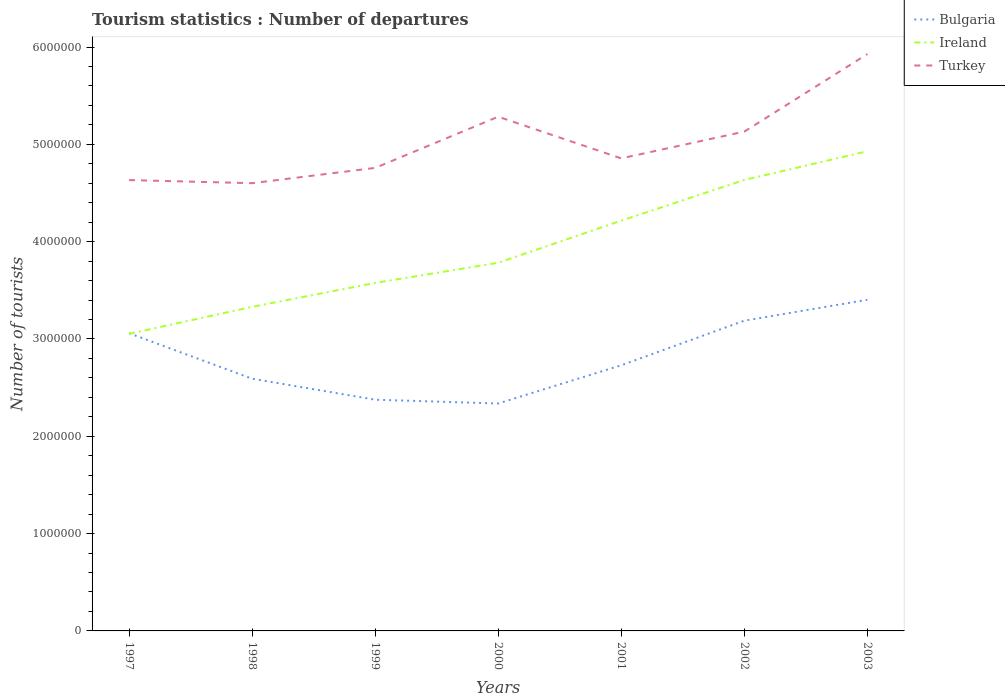How many different coloured lines are there?
Make the answer very short. 3. Does the line corresponding to Ireland intersect with the line corresponding to Bulgaria?
Your response must be concise. Yes. Across all years, what is the maximum number of tourist departures in Ireland?
Your answer should be very brief. 3.05e+06. What is the total number of tourist departures in Ireland in the graph?
Offer a terse response. -8.51e+05. What is the difference between the highest and the second highest number of tourist departures in Ireland?
Make the answer very short. 1.88e+06. What is the difference between the highest and the lowest number of tourist departures in Bulgaria?
Give a very brief answer. 3. How many lines are there?
Make the answer very short. 3. How many years are there in the graph?
Your answer should be very brief. 7. What is the difference between two consecutive major ticks on the Y-axis?
Ensure brevity in your answer.  1.00e+06. How many legend labels are there?
Provide a short and direct response. 3. How are the legend labels stacked?
Offer a terse response. Vertical. What is the title of the graph?
Ensure brevity in your answer.  Tourism statistics : Number of departures. What is the label or title of the Y-axis?
Your answer should be very brief. Number of tourists. What is the Number of tourists in Bulgaria in 1997?
Offer a very short reply. 3.06e+06. What is the Number of tourists of Ireland in 1997?
Provide a succinct answer. 3.05e+06. What is the Number of tourists in Turkey in 1997?
Ensure brevity in your answer.  4.63e+06. What is the Number of tourists in Bulgaria in 1998?
Offer a very short reply. 2.59e+06. What is the Number of tourists of Ireland in 1998?
Offer a very short reply. 3.33e+06. What is the Number of tourists in Turkey in 1998?
Make the answer very short. 4.60e+06. What is the Number of tourists of Bulgaria in 1999?
Keep it short and to the point. 2.38e+06. What is the Number of tourists in Ireland in 1999?
Ensure brevity in your answer.  3.58e+06. What is the Number of tourists in Turkey in 1999?
Provide a succinct answer. 4.76e+06. What is the Number of tourists of Bulgaria in 2000?
Make the answer very short. 2.34e+06. What is the Number of tourists of Ireland in 2000?
Keep it short and to the point. 3.78e+06. What is the Number of tourists of Turkey in 2000?
Make the answer very short. 5.28e+06. What is the Number of tourists of Bulgaria in 2001?
Ensure brevity in your answer.  2.73e+06. What is the Number of tourists of Ireland in 2001?
Offer a terse response. 4.22e+06. What is the Number of tourists in Turkey in 2001?
Provide a short and direct response. 4.86e+06. What is the Number of tourists of Bulgaria in 2002?
Give a very brief answer. 3.19e+06. What is the Number of tourists in Ireland in 2002?
Offer a very short reply. 4.63e+06. What is the Number of tourists in Turkey in 2002?
Your response must be concise. 5.13e+06. What is the Number of tourists of Bulgaria in 2003?
Make the answer very short. 3.40e+06. What is the Number of tourists in Ireland in 2003?
Your answer should be very brief. 4.93e+06. What is the Number of tourists of Turkey in 2003?
Your answer should be very brief. 5.93e+06. Across all years, what is the maximum Number of tourists in Bulgaria?
Provide a short and direct response. 3.40e+06. Across all years, what is the maximum Number of tourists in Ireland?
Ensure brevity in your answer.  4.93e+06. Across all years, what is the maximum Number of tourists in Turkey?
Provide a short and direct response. 5.93e+06. Across all years, what is the minimum Number of tourists in Bulgaria?
Offer a terse response. 2.34e+06. Across all years, what is the minimum Number of tourists in Ireland?
Your answer should be very brief. 3.05e+06. Across all years, what is the minimum Number of tourists in Turkey?
Your response must be concise. 4.60e+06. What is the total Number of tourists of Bulgaria in the graph?
Offer a terse response. 1.97e+07. What is the total Number of tourists of Ireland in the graph?
Keep it short and to the point. 2.75e+07. What is the total Number of tourists of Turkey in the graph?
Keep it short and to the point. 3.52e+07. What is the difference between the Number of tourists in Bulgaria in 1997 and that in 1998?
Ensure brevity in your answer.  4.67e+05. What is the difference between the Number of tourists in Ireland in 1997 and that in 1998?
Provide a succinct answer. -2.77e+05. What is the difference between the Number of tourists of Turkey in 1997 and that in 1998?
Provide a short and direct response. 3.20e+04. What is the difference between the Number of tourists of Bulgaria in 1997 and that in 1999?
Provide a short and direct response. 6.83e+05. What is the difference between the Number of tourists in Ireland in 1997 and that in 1999?
Keep it short and to the point. -5.23e+05. What is the difference between the Number of tourists in Turkey in 1997 and that in 1999?
Give a very brief answer. -1.25e+05. What is the difference between the Number of tourists of Bulgaria in 1997 and that in 2000?
Your answer should be compact. 7.22e+05. What is the difference between the Number of tourists of Ireland in 1997 and that in 2000?
Keep it short and to the point. -7.30e+05. What is the difference between the Number of tourists of Turkey in 1997 and that in 2000?
Ensure brevity in your answer.  -6.51e+05. What is the difference between the Number of tourists of Bulgaria in 1997 and that in 2001?
Provide a short and direct response. 3.29e+05. What is the difference between the Number of tourists of Ireland in 1997 and that in 2001?
Make the answer very short. -1.16e+06. What is the difference between the Number of tourists of Turkey in 1997 and that in 2001?
Offer a terse response. -2.23e+05. What is the difference between the Number of tourists of Bulgaria in 1997 and that in 2002?
Offer a very short reply. -1.29e+05. What is the difference between the Number of tourists of Ireland in 1997 and that in 2002?
Offer a very short reply. -1.58e+06. What is the difference between the Number of tourists in Turkey in 1997 and that in 2002?
Make the answer very short. -4.98e+05. What is the difference between the Number of tourists of Bulgaria in 1997 and that in 2003?
Offer a very short reply. -3.44e+05. What is the difference between the Number of tourists of Ireland in 1997 and that in 2003?
Your answer should be compact. -1.88e+06. What is the difference between the Number of tourists in Turkey in 1997 and that in 2003?
Keep it short and to the point. -1.30e+06. What is the difference between the Number of tourists of Bulgaria in 1998 and that in 1999?
Give a very brief answer. 2.16e+05. What is the difference between the Number of tourists in Ireland in 1998 and that in 1999?
Your answer should be very brief. -2.46e+05. What is the difference between the Number of tourists of Turkey in 1998 and that in 1999?
Offer a very short reply. -1.57e+05. What is the difference between the Number of tourists of Bulgaria in 1998 and that in 2000?
Offer a very short reply. 2.55e+05. What is the difference between the Number of tourists of Ireland in 1998 and that in 2000?
Your response must be concise. -4.53e+05. What is the difference between the Number of tourists of Turkey in 1998 and that in 2000?
Ensure brevity in your answer.  -6.83e+05. What is the difference between the Number of tourists in Bulgaria in 1998 and that in 2001?
Give a very brief answer. -1.38e+05. What is the difference between the Number of tourists of Ireland in 1998 and that in 2001?
Offer a terse response. -8.86e+05. What is the difference between the Number of tourists in Turkey in 1998 and that in 2001?
Offer a very short reply. -2.55e+05. What is the difference between the Number of tourists of Bulgaria in 1998 and that in 2002?
Give a very brief answer. -5.96e+05. What is the difference between the Number of tourists in Ireland in 1998 and that in 2002?
Offer a terse response. -1.30e+06. What is the difference between the Number of tourists in Turkey in 1998 and that in 2002?
Your answer should be compact. -5.30e+05. What is the difference between the Number of tourists in Bulgaria in 1998 and that in 2003?
Offer a terse response. -8.11e+05. What is the difference between the Number of tourists of Ireland in 1998 and that in 2003?
Your response must be concise. -1.60e+06. What is the difference between the Number of tourists in Turkey in 1998 and that in 2003?
Keep it short and to the point. -1.33e+06. What is the difference between the Number of tourists of Bulgaria in 1999 and that in 2000?
Offer a terse response. 3.90e+04. What is the difference between the Number of tourists in Ireland in 1999 and that in 2000?
Your answer should be very brief. -2.07e+05. What is the difference between the Number of tourists of Turkey in 1999 and that in 2000?
Ensure brevity in your answer.  -5.26e+05. What is the difference between the Number of tourists in Bulgaria in 1999 and that in 2001?
Provide a short and direct response. -3.54e+05. What is the difference between the Number of tourists in Ireland in 1999 and that in 2001?
Offer a terse response. -6.40e+05. What is the difference between the Number of tourists in Turkey in 1999 and that in 2001?
Provide a succinct answer. -9.80e+04. What is the difference between the Number of tourists of Bulgaria in 1999 and that in 2002?
Your answer should be very brief. -8.12e+05. What is the difference between the Number of tourists of Ireland in 1999 and that in 2002?
Offer a very short reply. -1.06e+06. What is the difference between the Number of tourists in Turkey in 1999 and that in 2002?
Offer a very short reply. -3.73e+05. What is the difference between the Number of tourists of Bulgaria in 1999 and that in 2003?
Offer a terse response. -1.03e+06. What is the difference between the Number of tourists in Ireland in 1999 and that in 2003?
Keep it short and to the point. -1.35e+06. What is the difference between the Number of tourists in Turkey in 1999 and that in 2003?
Ensure brevity in your answer.  -1.17e+06. What is the difference between the Number of tourists in Bulgaria in 2000 and that in 2001?
Your answer should be very brief. -3.93e+05. What is the difference between the Number of tourists in Ireland in 2000 and that in 2001?
Your response must be concise. -4.33e+05. What is the difference between the Number of tourists in Turkey in 2000 and that in 2001?
Provide a succinct answer. 4.28e+05. What is the difference between the Number of tourists of Bulgaria in 2000 and that in 2002?
Provide a succinct answer. -8.51e+05. What is the difference between the Number of tourists of Ireland in 2000 and that in 2002?
Offer a terse response. -8.51e+05. What is the difference between the Number of tourists in Turkey in 2000 and that in 2002?
Your response must be concise. 1.53e+05. What is the difference between the Number of tourists of Bulgaria in 2000 and that in 2003?
Ensure brevity in your answer.  -1.07e+06. What is the difference between the Number of tourists in Ireland in 2000 and that in 2003?
Make the answer very short. -1.15e+06. What is the difference between the Number of tourists of Turkey in 2000 and that in 2003?
Ensure brevity in your answer.  -6.44e+05. What is the difference between the Number of tourists in Bulgaria in 2001 and that in 2002?
Make the answer very short. -4.58e+05. What is the difference between the Number of tourists in Ireland in 2001 and that in 2002?
Offer a very short reply. -4.18e+05. What is the difference between the Number of tourists of Turkey in 2001 and that in 2002?
Give a very brief answer. -2.75e+05. What is the difference between the Number of tourists of Bulgaria in 2001 and that in 2003?
Provide a short and direct response. -6.73e+05. What is the difference between the Number of tourists in Ireland in 2001 and that in 2003?
Offer a very short reply. -7.13e+05. What is the difference between the Number of tourists of Turkey in 2001 and that in 2003?
Give a very brief answer. -1.07e+06. What is the difference between the Number of tourists in Bulgaria in 2002 and that in 2003?
Provide a succinct answer. -2.15e+05. What is the difference between the Number of tourists of Ireland in 2002 and that in 2003?
Your response must be concise. -2.95e+05. What is the difference between the Number of tourists in Turkey in 2002 and that in 2003?
Provide a succinct answer. -7.97e+05. What is the difference between the Number of tourists in Bulgaria in 1997 and the Number of tourists in Ireland in 1998?
Provide a short and direct response. -2.71e+05. What is the difference between the Number of tourists in Bulgaria in 1997 and the Number of tourists in Turkey in 1998?
Keep it short and to the point. -1.54e+06. What is the difference between the Number of tourists in Ireland in 1997 and the Number of tourists in Turkey in 1998?
Ensure brevity in your answer.  -1.55e+06. What is the difference between the Number of tourists in Bulgaria in 1997 and the Number of tourists in Ireland in 1999?
Provide a succinct answer. -5.17e+05. What is the difference between the Number of tourists of Bulgaria in 1997 and the Number of tourists of Turkey in 1999?
Provide a short and direct response. -1.70e+06. What is the difference between the Number of tourists in Ireland in 1997 and the Number of tourists in Turkey in 1999?
Your answer should be compact. -1.70e+06. What is the difference between the Number of tourists in Bulgaria in 1997 and the Number of tourists in Ireland in 2000?
Provide a succinct answer. -7.24e+05. What is the difference between the Number of tourists in Bulgaria in 1997 and the Number of tourists in Turkey in 2000?
Your answer should be very brief. -2.22e+06. What is the difference between the Number of tourists of Ireland in 1997 and the Number of tourists of Turkey in 2000?
Your response must be concise. -2.23e+06. What is the difference between the Number of tourists in Bulgaria in 1997 and the Number of tourists in Ireland in 2001?
Ensure brevity in your answer.  -1.16e+06. What is the difference between the Number of tourists in Bulgaria in 1997 and the Number of tourists in Turkey in 2001?
Offer a terse response. -1.80e+06. What is the difference between the Number of tourists in Ireland in 1997 and the Number of tourists in Turkey in 2001?
Ensure brevity in your answer.  -1.80e+06. What is the difference between the Number of tourists of Bulgaria in 1997 and the Number of tourists of Ireland in 2002?
Offer a very short reply. -1.58e+06. What is the difference between the Number of tourists of Bulgaria in 1997 and the Number of tourists of Turkey in 2002?
Ensure brevity in your answer.  -2.07e+06. What is the difference between the Number of tourists of Ireland in 1997 and the Number of tourists of Turkey in 2002?
Ensure brevity in your answer.  -2.08e+06. What is the difference between the Number of tourists of Bulgaria in 1997 and the Number of tourists of Ireland in 2003?
Your response must be concise. -1.87e+06. What is the difference between the Number of tourists of Bulgaria in 1997 and the Number of tourists of Turkey in 2003?
Ensure brevity in your answer.  -2.87e+06. What is the difference between the Number of tourists in Ireland in 1997 and the Number of tourists in Turkey in 2003?
Make the answer very short. -2.88e+06. What is the difference between the Number of tourists of Bulgaria in 1998 and the Number of tourists of Ireland in 1999?
Ensure brevity in your answer.  -9.84e+05. What is the difference between the Number of tourists of Bulgaria in 1998 and the Number of tourists of Turkey in 1999?
Make the answer very short. -2.17e+06. What is the difference between the Number of tourists in Ireland in 1998 and the Number of tourists in Turkey in 1999?
Your answer should be very brief. -1.43e+06. What is the difference between the Number of tourists of Bulgaria in 1998 and the Number of tourists of Ireland in 2000?
Ensure brevity in your answer.  -1.19e+06. What is the difference between the Number of tourists in Bulgaria in 1998 and the Number of tourists in Turkey in 2000?
Offer a very short reply. -2.69e+06. What is the difference between the Number of tourists in Ireland in 1998 and the Number of tourists in Turkey in 2000?
Make the answer very short. -1.95e+06. What is the difference between the Number of tourists in Bulgaria in 1998 and the Number of tourists in Ireland in 2001?
Ensure brevity in your answer.  -1.62e+06. What is the difference between the Number of tourists of Bulgaria in 1998 and the Number of tourists of Turkey in 2001?
Your answer should be compact. -2.26e+06. What is the difference between the Number of tourists in Ireland in 1998 and the Number of tourists in Turkey in 2001?
Your answer should be compact. -1.53e+06. What is the difference between the Number of tourists of Bulgaria in 1998 and the Number of tourists of Ireland in 2002?
Make the answer very short. -2.04e+06. What is the difference between the Number of tourists in Bulgaria in 1998 and the Number of tourists in Turkey in 2002?
Make the answer very short. -2.54e+06. What is the difference between the Number of tourists of Ireland in 1998 and the Number of tourists of Turkey in 2002?
Your response must be concise. -1.80e+06. What is the difference between the Number of tourists in Bulgaria in 1998 and the Number of tourists in Ireland in 2003?
Your answer should be very brief. -2.34e+06. What is the difference between the Number of tourists in Bulgaria in 1998 and the Number of tourists in Turkey in 2003?
Keep it short and to the point. -3.34e+06. What is the difference between the Number of tourists of Ireland in 1998 and the Number of tourists of Turkey in 2003?
Ensure brevity in your answer.  -2.60e+06. What is the difference between the Number of tourists of Bulgaria in 1999 and the Number of tourists of Ireland in 2000?
Offer a very short reply. -1.41e+06. What is the difference between the Number of tourists of Bulgaria in 1999 and the Number of tourists of Turkey in 2000?
Make the answer very short. -2.91e+06. What is the difference between the Number of tourists in Ireland in 1999 and the Number of tourists in Turkey in 2000?
Keep it short and to the point. -1.71e+06. What is the difference between the Number of tourists in Bulgaria in 1999 and the Number of tourists in Ireland in 2001?
Your answer should be compact. -1.84e+06. What is the difference between the Number of tourists in Bulgaria in 1999 and the Number of tourists in Turkey in 2001?
Make the answer very short. -2.48e+06. What is the difference between the Number of tourists in Ireland in 1999 and the Number of tourists in Turkey in 2001?
Keep it short and to the point. -1.28e+06. What is the difference between the Number of tourists in Bulgaria in 1999 and the Number of tourists in Ireland in 2002?
Keep it short and to the point. -2.26e+06. What is the difference between the Number of tourists in Bulgaria in 1999 and the Number of tourists in Turkey in 2002?
Offer a very short reply. -2.76e+06. What is the difference between the Number of tourists in Ireland in 1999 and the Number of tourists in Turkey in 2002?
Give a very brief answer. -1.56e+06. What is the difference between the Number of tourists of Bulgaria in 1999 and the Number of tourists of Ireland in 2003?
Provide a short and direct response. -2.55e+06. What is the difference between the Number of tourists of Bulgaria in 1999 and the Number of tourists of Turkey in 2003?
Your answer should be compact. -3.55e+06. What is the difference between the Number of tourists in Ireland in 1999 and the Number of tourists in Turkey in 2003?
Your answer should be very brief. -2.35e+06. What is the difference between the Number of tourists of Bulgaria in 2000 and the Number of tourists of Ireland in 2001?
Provide a succinct answer. -1.88e+06. What is the difference between the Number of tourists of Bulgaria in 2000 and the Number of tourists of Turkey in 2001?
Your answer should be very brief. -2.52e+06. What is the difference between the Number of tourists in Ireland in 2000 and the Number of tourists in Turkey in 2001?
Your answer should be compact. -1.07e+06. What is the difference between the Number of tourists in Bulgaria in 2000 and the Number of tourists in Ireland in 2002?
Keep it short and to the point. -2.30e+06. What is the difference between the Number of tourists of Bulgaria in 2000 and the Number of tourists of Turkey in 2002?
Offer a terse response. -2.79e+06. What is the difference between the Number of tourists in Ireland in 2000 and the Number of tourists in Turkey in 2002?
Provide a short and direct response. -1.35e+06. What is the difference between the Number of tourists in Bulgaria in 2000 and the Number of tourists in Ireland in 2003?
Your response must be concise. -2.59e+06. What is the difference between the Number of tourists of Bulgaria in 2000 and the Number of tourists of Turkey in 2003?
Ensure brevity in your answer.  -3.59e+06. What is the difference between the Number of tourists in Ireland in 2000 and the Number of tourists in Turkey in 2003?
Provide a short and direct response. -2.14e+06. What is the difference between the Number of tourists of Bulgaria in 2001 and the Number of tourists of Ireland in 2002?
Your response must be concise. -1.90e+06. What is the difference between the Number of tourists in Bulgaria in 2001 and the Number of tourists in Turkey in 2002?
Provide a succinct answer. -2.40e+06. What is the difference between the Number of tourists in Ireland in 2001 and the Number of tourists in Turkey in 2002?
Provide a short and direct response. -9.15e+05. What is the difference between the Number of tourists in Bulgaria in 2001 and the Number of tourists in Ireland in 2003?
Provide a short and direct response. -2.20e+06. What is the difference between the Number of tourists in Bulgaria in 2001 and the Number of tourists in Turkey in 2003?
Your response must be concise. -3.20e+06. What is the difference between the Number of tourists of Ireland in 2001 and the Number of tourists of Turkey in 2003?
Your response must be concise. -1.71e+06. What is the difference between the Number of tourists of Bulgaria in 2002 and the Number of tourists of Ireland in 2003?
Offer a very short reply. -1.74e+06. What is the difference between the Number of tourists of Bulgaria in 2002 and the Number of tourists of Turkey in 2003?
Make the answer very short. -2.74e+06. What is the difference between the Number of tourists of Ireland in 2002 and the Number of tourists of Turkey in 2003?
Keep it short and to the point. -1.29e+06. What is the average Number of tourists of Bulgaria per year?
Offer a terse response. 2.81e+06. What is the average Number of tourists of Ireland per year?
Ensure brevity in your answer.  3.93e+06. What is the average Number of tourists in Turkey per year?
Ensure brevity in your answer.  5.03e+06. In the year 1997, what is the difference between the Number of tourists of Bulgaria and Number of tourists of Ireland?
Your answer should be very brief. 6000. In the year 1997, what is the difference between the Number of tourists of Bulgaria and Number of tourists of Turkey?
Your answer should be compact. -1.57e+06. In the year 1997, what is the difference between the Number of tourists in Ireland and Number of tourists in Turkey?
Ensure brevity in your answer.  -1.58e+06. In the year 1998, what is the difference between the Number of tourists of Bulgaria and Number of tourists of Ireland?
Give a very brief answer. -7.38e+05. In the year 1998, what is the difference between the Number of tourists of Bulgaria and Number of tourists of Turkey?
Give a very brief answer. -2.01e+06. In the year 1998, what is the difference between the Number of tourists of Ireland and Number of tourists of Turkey?
Your response must be concise. -1.27e+06. In the year 1999, what is the difference between the Number of tourists of Bulgaria and Number of tourists of Ireland?
Ensure brevity in your answer.  -1.20e+06. In the year 1999, what is the difference between the Number of tourists of Bulgaria and Number of tourists of Turkey?
Provide a short and direct response. -2.38e+06. In the year 1999, what is the difference between the Number of tourists in Ireland and Number of tourists in Turkey?
Provide a succinct answer. -1.18e+06. In the year 2000, what is the difference between the Number of tourists of Bulgaria and Number of tourists of Ireland?
Your answer should be compact. -1.45e+06. In the year 2000, what is the difference between the Number of tourists in Bulgaria and Number of tourists in Turkey?
Offer a very short reply. -2.95e+06. In the year 2000, what is the difference between the Number of tourists in Ireland and Number of tourists in Turkey?
Provide a short and direct response. -1.50e+06. In the year 2001, what is the difference between the Number of tourists of Bulgaria and Number of tourists of Ireland?
Your answer should be compact. -1.49e+06. In the year 2001, what is the difference between the Number of tourists of Bulgaria and Number of tourists of Turkey?
Your response must be concise. -2.13e+06. In the year 2001, what is the difference between the Number of tourists of Ireland and Number of tourists of Turkey?
Make the answer very short. -6.40e+05. In the year 2002, what is the difference between the Number of tourists in Bulgaria and Number of tourists in Ireland?
Offer a very short reply. -1.45e+06. In the year 2002, what is the difference between the Number of tourists of Bulgaria and Number of tourists of Turkey?
Ensure brevity in your answer.  -1.94e+06. In the year 2002, what is the difference between the Number of tourists of Ireland and Number of tourists of Turkey?
Offer a very short reply. -4.97e+05. In the year 2003, what is the difference between the Number of tourists of Bulgaria and Number of tourists of Ireland?
Offer a very short reply. -1.53e+06. In the year 2003, what is the difference between the Number of tourists in Bulgaria and Number of tourists in Turkey?
Provide a succinct answer. -2.52e+06. In the year 2003, what is the difference between the Number of tourists in Ireland and Number of tourists in Turkey?
Keep it short and to the point. -9.99e+05. What is the ratio of the Number of tourists in Bulgaria in 1997 to that in 1998?
Your answer should be very brief. 1.18. What is the ratio of the Number of tourists of Ireland in 1997 to that in 1998?
Provide a short and direct response. 0.92. What is the ratio of the Number of tourists of Bulgaria in 1997 to that in 1999?
Keep it short and to the point. 1.29. What is the ratio of the Number of tourists of Ireland in 1997 to that in 1999?
Offer a very short reply. 0.85. What is the ratio of the Number of tourists of Turkey in 1997 to that in 1999?
Your response must be concise. 0.97. What is the ratio of the Number of tourists of Bulgaria in 1997 to that in 2000?
Ensure brevity in your answer.  1.31. What is the ratio of the Number of tourists in Ireland in 1997 to that in 2000?
Keep it short and to the point. 0.81. What is the ratio of the Number of tourists in Turkey in 1997 to that in 2000?
Keep it short and to the point. 0.88. What is the ratio of the Number of tourists in Bulgaria in 1997 to that in 2001?
Provide a succinct answer. 1.12. What is the ratio of the Number of tourists in Ireland in 1997 to that in 2001?
Offer a very short reply. 0.72. What is the ratio of the Number of tourists in Turkey in 1997 to that in 2001?
Make the answer very short. 0.95. What is the ratio of the Number of tourists in Bulgaria in 1997 to that in 2002?
Keep it short and to the point. 0.96. What is the ratio of the Number of tourists of Ireland in 1997 to that in 2002?
Offer a terse response. 0.66. What is the ratio of the Number of tourists in Turkey in 1997 to that in 2002?
Offer a very short reply. 0.9. What is the ratio of the Number of tourists in Bulgaria in 1997 to that in 2003?
Make the answer very short. 0.9. What is the ratio of the Number of tourists in Ireland in 1997 to that in 2003?
Your answer should be compact. 0.62. What is the ratio of the Number of tourists of Turkey in 1997 to that in 2003?
Ensure brevity in your answer.  0.78. What is the ratio of the Number of tourists in Bulgaria in 1998 to that in 1999?
Offer a terse response. 1.09. What is the ratio of the Number of tourists in Ireland in 1998 to that in 1999?
Give a very brief answer. 0.93. What is the ratio of the Number of tourists of Turkey in 1998 to that in 1999?
Your response must be concise. 0.97. What is the ratio of the Number of tourists of Bulgaria in 1998 to that in 2000?
Offer a very short reply. 1.11. What is the ratio of the Number of tourists of Ireland in 1998 to that in 2000?
Offer a terse response. 0.88. What is the ratio of the Number of tourists in Turkey in 1998 to that in 2000?
Ensure brevity in your answer.  0.87. What is the ratio of the Number of tourists of Bulgaria in 1998 to that in 2001?
Provide a short and direct response. 0.95. What is the ratio of the Number of tourists of Ireland in 1998 to that in 2001?
Make the answer very short. 0.79. What is the ratio of the Number of tourists of Turkey in 1998 to that in 2001?
Your answer should be very brief. 0.95. What is the ratio of the Number of tourists in Bulgaria in 1998 to that in 2002?
Keep it short and to the point. 0.81. What is the ratio of the Number of tourists of Ireland in 1998 to that in 2002?
Provide a succinct answer. 0.72. What is the ratio of the Number of tourists in Turkey in 1998 to that in 2002?
Provide a short and direct response. 0.9. What is the ratio of the Number of tourists of Bulgaria in 1998 to that in 2003?
Give a very brief answer. 0.76. What is the ratio of the Number of tourists of Ireland in 1998 to that in 2003?
Your answer should be very brief. 0.68. What is the ratio of the Number of tourists in Turkey in 1998 to that in 2003?
Offer a very short reply. 0.78. What is the ratio of the Number of tourists of Bulgaria in 1999 to that in 2000?
Offer a terse response. 1.02. What is the ratio of the Number of tourists in Ireland in 1999 to that in 2000?
Provide a short and direct response. 0.95. What is the ratio of the Number of tourists of Turkey in 1999 to that in 2000?
Provide a short and direct response. 0.9. What is the ratio of the Number of tourists in Bulgaria in 1999 to that in 2001?
Your answer should be very brief. 0.87. What is the ratio of the Number of tourists of Ireland in 1999 to that in 2001?
Give a very brief answer. 0.85. What is the ratio of the Number of tourists in Turkey in 1999 to that in 2001?
Make the answer very short. 0.98. What is the ratio of the Number of tourists of Bulgaria in 1999 to that in 2002?
Offer a terse response. 0.75. What is the ratio of the Number of tourists of Ireland in 1999 to that in 2002?
Offer a terse response. 0.77. What is the ratio of the Number of tourists in Turkey in 1999 to that in 2002?
Ensure brevity in your answer.  0.93. What is the ratio of the Number of tourists of Bulgaria in 1999 to that in 2003?
Your answer should be very brief. 0.7. What is the ratio of the Number of tourists of Ireland in 1999 to that in 2003?
Offer a very short reply. 0.73. What is the ratio of the Number of tourists in Turkey in 1999 to that in 2003?
Provide a short and direct response. 0.8. What is the ratio of the Number of tourists of Bulgaria in 2000 to that in 2001?
Your answer should be compact. 0.86. What is the ratio of the Number of tourists in Ireland in 2000 to that in 2001?
Make the answer very short. 0.9. What is the ratio of the Number of tourists of Turkey in 2000 to that in 2001?
Provide a short and direct response. 1.09. What is the ratio of the Number of tourists in Bulgaria in 2000 to that in 2002?
Make the answer very short. 0.73. What is the ratio of the Number of tourists of Ireland in 2000 to that in 2002?
Ensure brevity in your answer.  0.82. What is the ratio of the Number of tourists in Turkey in 2000 to that in 2002?
Offer a terse response. 1.03. What is the ratio of the Number of tourists of Bulgaria in 2000 to that in 2003?
Provide a short and direct response. 0.69. What is the ratio of the Number of tourists of Ireland in 2000 to that in 2003?
Your response must be concise. 0.77. What is the ratio of the Number of tourists of Turkey in 2000 to that in 2003?
Your answer should be very brief. 0.89. What is the ratio of the Number of tourists of Bulgaria in 2001 to that in 2002?
Keep it short and to the point. 0.86. What is the ratio of the Number of tourists in Ireland in 2001 to that in 2002?
Provide a succinct answer. 0.91. What is the ratio of the Number of tourists of Turkey in 2001 to that in 2002?
Your answer should be compact. 0.95. What is the ratio of the Number of tourists in Bulgaria in 2001 to that in 2003?
Offer a very short reply. 0.8. What is the ratio of the Number of tourists in Ireland in 2001 to that in 2003?
Ensure brevity in your answer.  0.86. What is the ratio of the Number of tourists in Turkey in 2001 to that in 2003?
Make the answer very short. 0.82. What is the ratio of the Number of tourists in Bulgaria in 2002 to that in 2003?
Ensure brevity in your answer.  0.94. What is the ratio of the Number of tourists in Ireland in 2002 to that in 2003?
Your answer should be compact. 0.94. What is the ratio of the Number of tourists in Turkey in 2002 to that in 2003?
Your answer should be compact. 0.87. What is the difference between the highest and the second highest Number of tourists in Bulgaria?
Ensure brevity in your answer.  2.15e+05. What is the difference between the highest and the second highest Number of tourists in Ireland?
Keep it short and to the point. 2.95e+05. What is the difference between the highest and the second highest Number of tourists of Turkey?
Make the answer very short. 6.44e+05. What is the difference between the highest and the lowest Number of tourists in Bulgaria?
Offer a very short reply. 1.07e+06. What is the difference between the highest and the lowest Number of tourists in Ireland?
Provide a short and direct response. 1.88e+06. What is the difference between the highest and the lowest Number of tourists in Turkey?
Keep it short and to the point. 1.33e+06. 